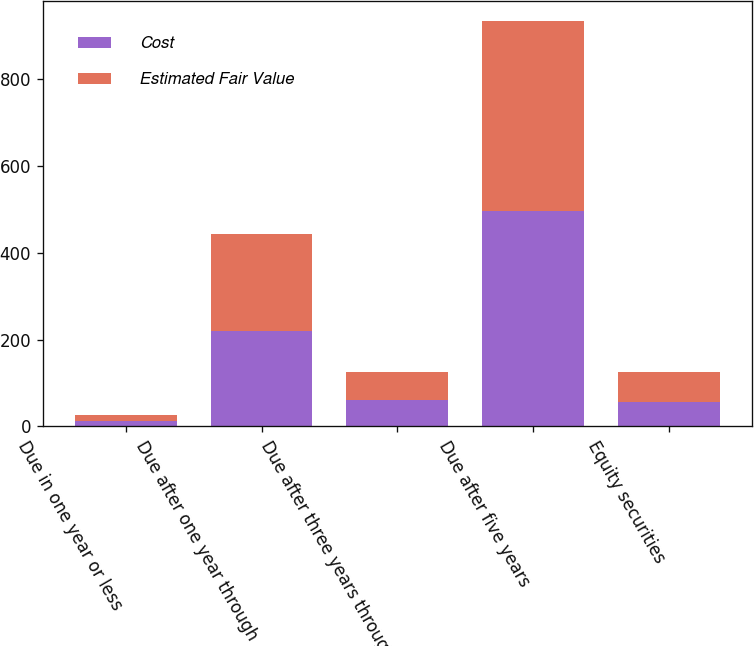Convert chart to OTSL. <chart><loc_0><loc_0><loc_500><loc_500><stacked_bar_chart><ecel><fcel>Due in one year or less<fcel>Due after one year through<fcel>Due after three years through<fcel>Due after five years<fcel>Equity securities<nl><fcel>Cost<fcel>13<fcel>221<fcel>62<fcel>497<fcel>56<nl><fcel>Estimated Fair Value<fcel>13<fcel>222<fcel>64<fcel>436<fcel>70<nl></chart> 